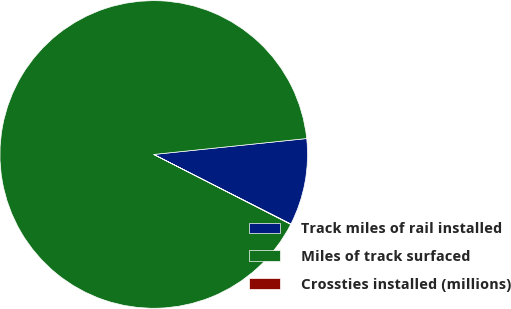<chart> <loc_0><loc_0><loc_500><loc_500><pie_chart><fcel>Track miles of rail installed<fcel>Miles of track surfaced<fcel>Crossties installed (millions)<nl><fcel>9.12%<fcel>90.83%<fcel>0.04%<nl></chart> 